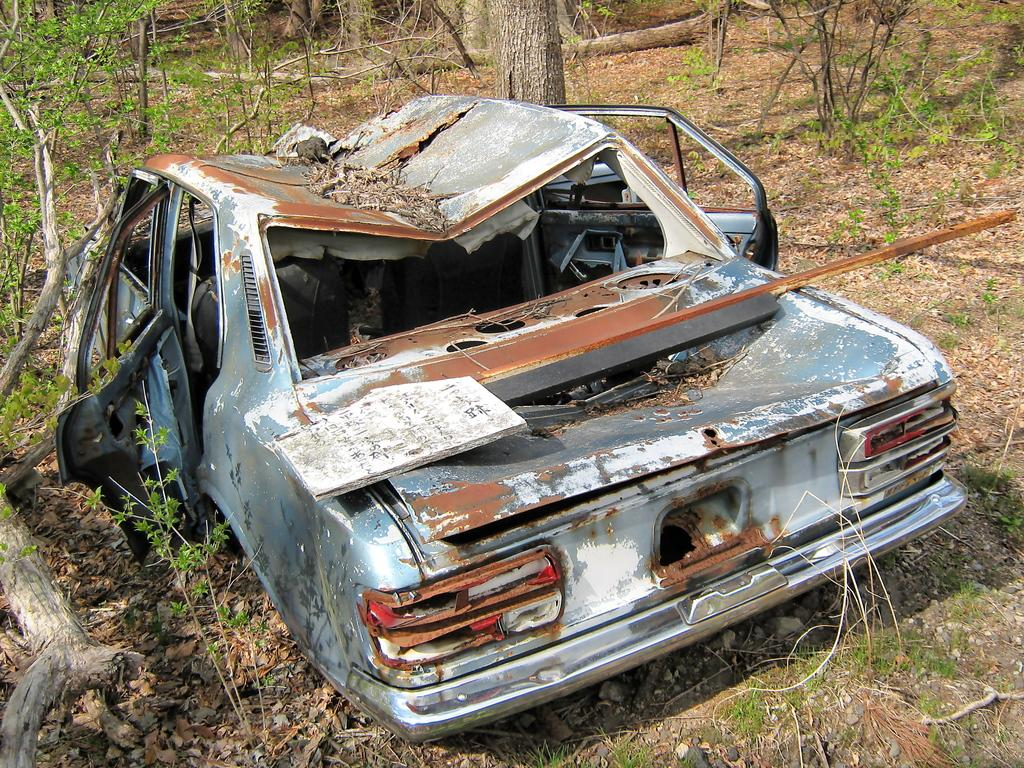What is located on the ground in the image? There is a vehicle on the ground in the image. What type of natural elements can be seen in the image? Dried leaves and grass are visible in the image. What can be seen in the background of the image? There are trees in the background of the image. Can you see a woman walking with a giraffe in the image? No, there is no woman or giraffe present in the image. 